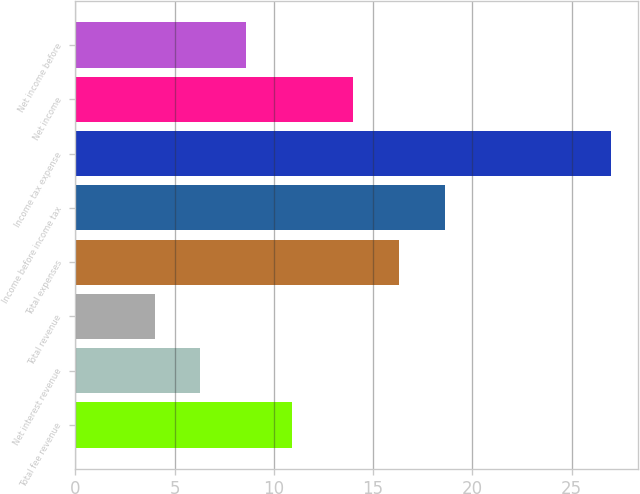Convert chart to OTSL. <chart><loc_0><loc_0><loc_500><loc_500><bar_chart><fcel>Total fee revenue<fcel>Net interest revenue<fcel>Total revenue<fcel>Total expenses<fcel>Income before income tax<fcel>Income tax expense<fcel>Net income<fcel>Net income before<nl><fcel>10.9<fcel>6.3<fcel>4<fcel>16.3<fcel>18.6<fcel>27<fcel>14<fcel>8.6<nl></chart> 